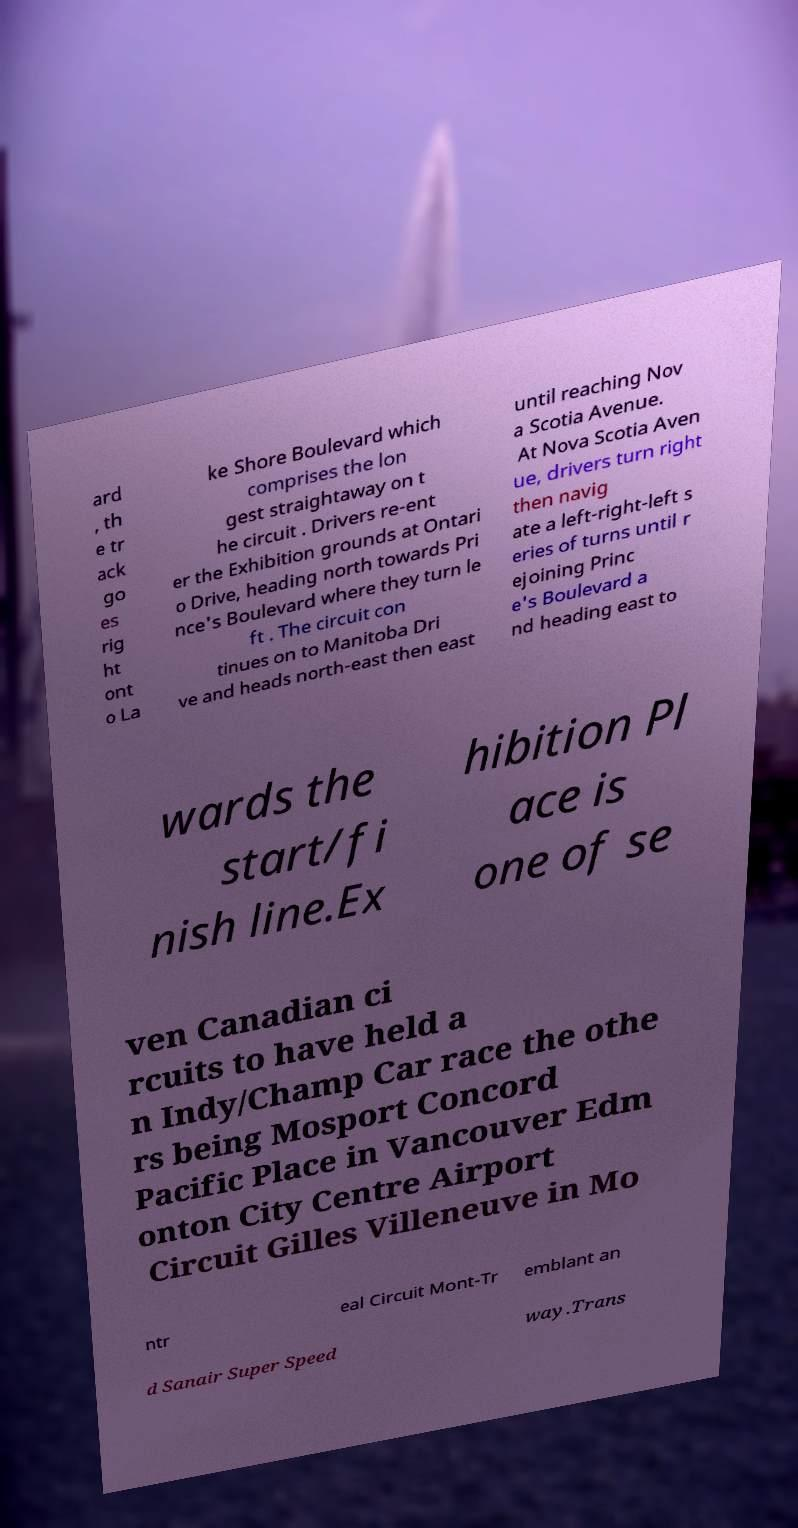Please identify and transcribe the text found in this image. ard , th e tr ack go es rig ht ont o La ke Shore Boulevard which comprises the lon gest straightaway on t he circuit . Drivers re-ent er the Exhibition grounds at Ontari o Drive, heading north towards Pri nce's Boulevard where they turn le ft . The circuit con tinues on to Manitoba Dri ve and heads north-east then east until reaching Nov a Scotia Avenue. At Nova Scotia Aven ue, drivers turn right then navig ate a left-right-left s eries of turns until r ejoining Princ e's Boulevard a nd heading east to wards the start/fi nish line.Ex hibition Pl ace is one of se ven Canadian ci rcuits to have held a n Indy/Champ Car race the othe rs being Mosport Concord Pacific Place in Vancouver Edm onton City Centre Airport Circuit Gilles Villeneuve in Mo ntr eal Circuit Mont-Tr emblant an d Sanair Super Speed way.Trans 